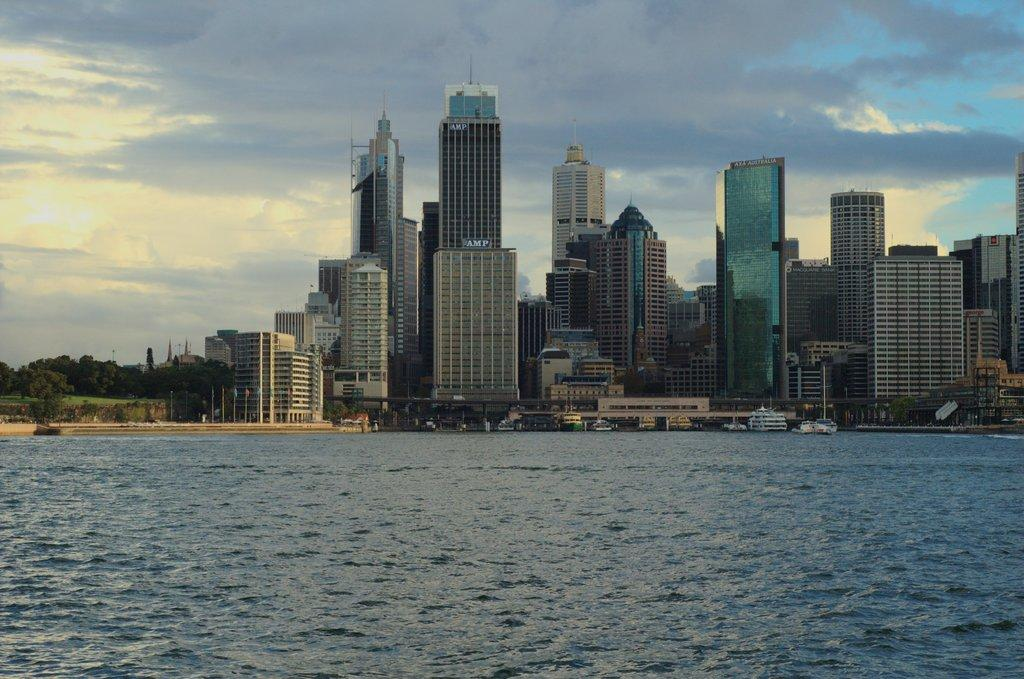What is the primary element visible in the image? There is water in the image. What type of structures can be seen in the image? There are buildings in the image. What type of vegetation is present in the image? There are trees in the image. What type of man-made objects can be seen in the image? There are poles in the image. What type of transportation is visible in the image? There are boats in the image. What else can be seen in the image besides the mentioned elements? There are some unspecified objects in the image. What is visible in the background of the image? The sky is visible in the background of the image. What can be observed in the sky? Clouds are present in the sky. How many chickens are present in the image? There are no chickens present in the image. What type of machine is being used by the partner in the image? There is no partner or machine present in the image. 